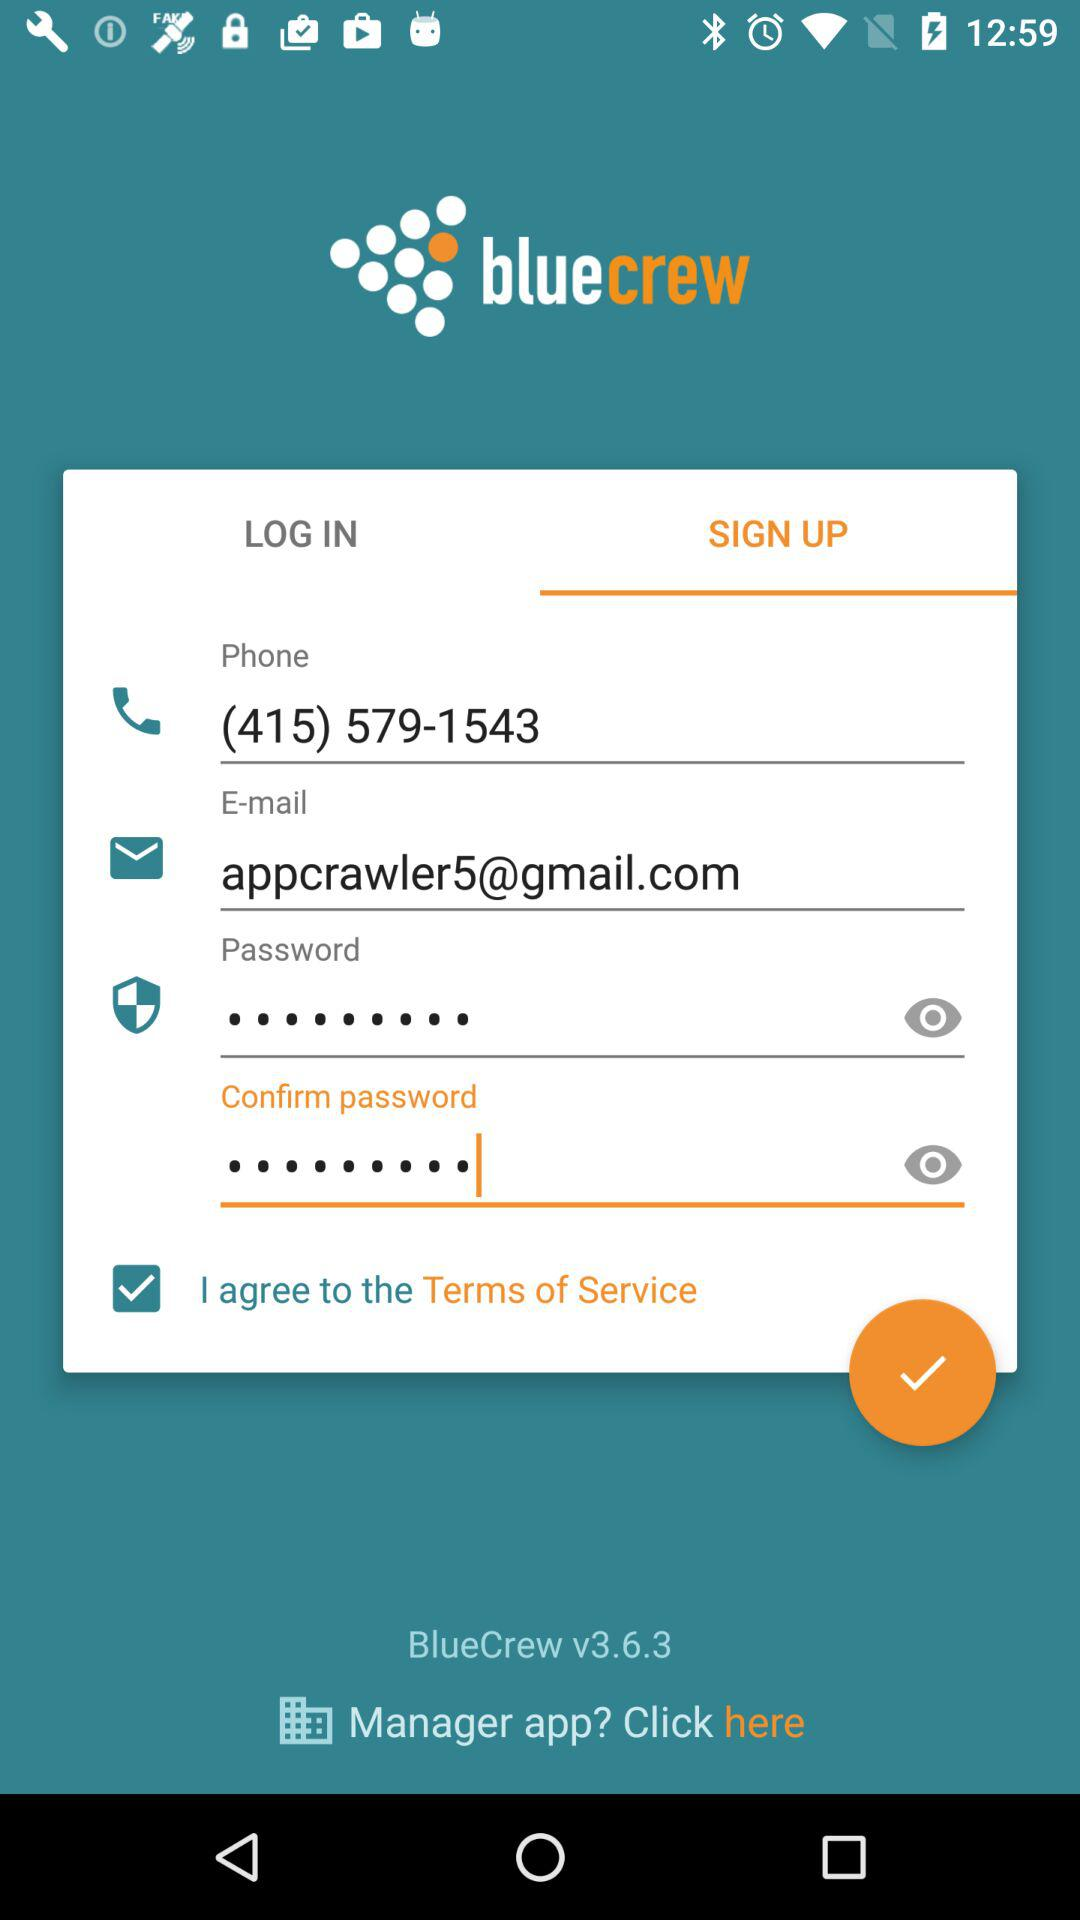What is the status of the option that includes agreement to the “Terms of Service”? The status is "on". 